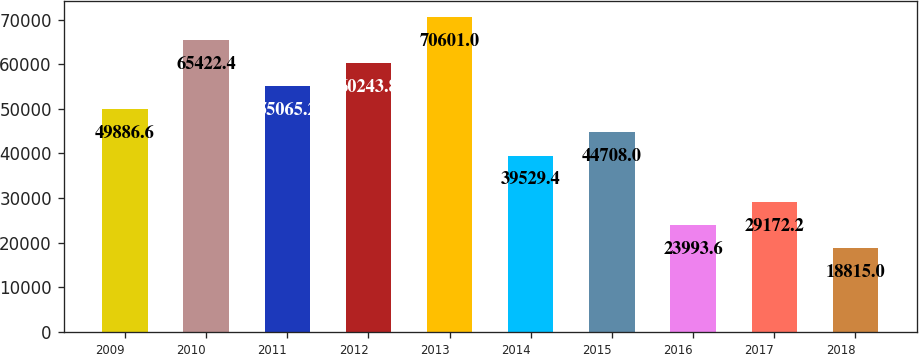<chart> <loc_0><loc_0><loc_500><loc_500><bar_chart><fcel>2009<fcel>2010<fcel>2011<fcel>2012<fcel>2013<fcel>2014<fcel>2015<fcel>2016<fcel>2017<fcel>2018<nl><fcel>49886.6<fcel>65422.4<fcel>55065.2<fcel>60243.8<fcel>70601<fcel>39529.4<fcel>44708<fcel>23993.6<fcel>29172.2<fcel>18815<nl></chart> 